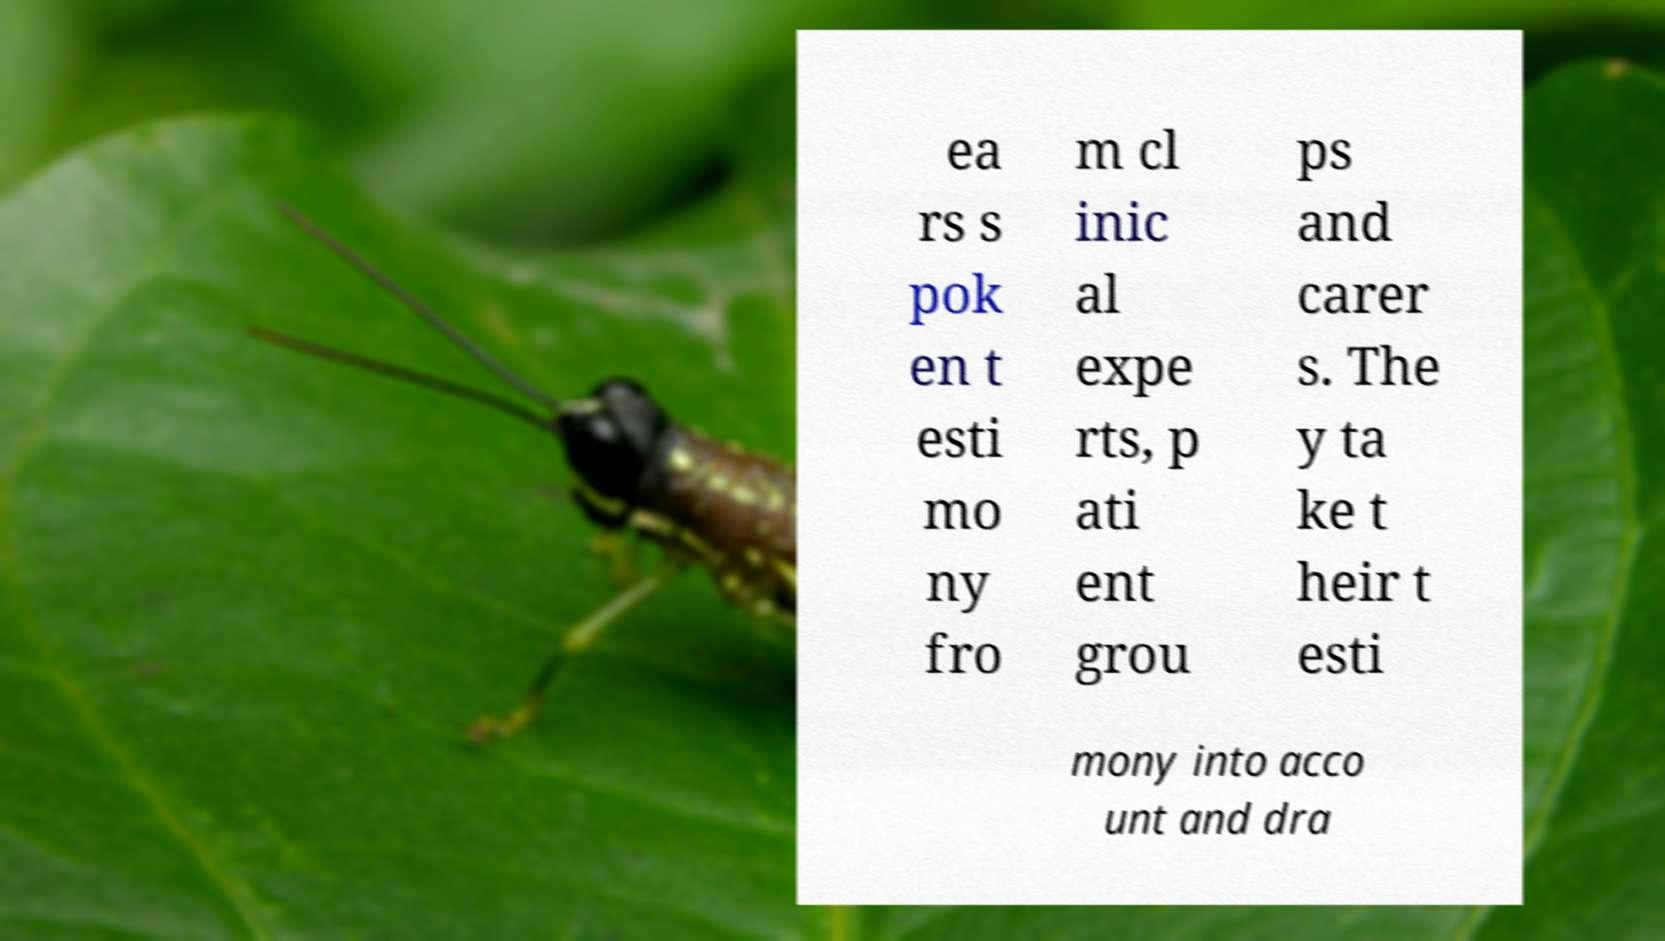I need the written content from this picture converted into text. Can you do that? ea rs s pok en t esti mo ny fro m cl inic al expe rts, p ati ent grou ps and carer s. The y ta ke t heir t esti mony into acco unt and dra 